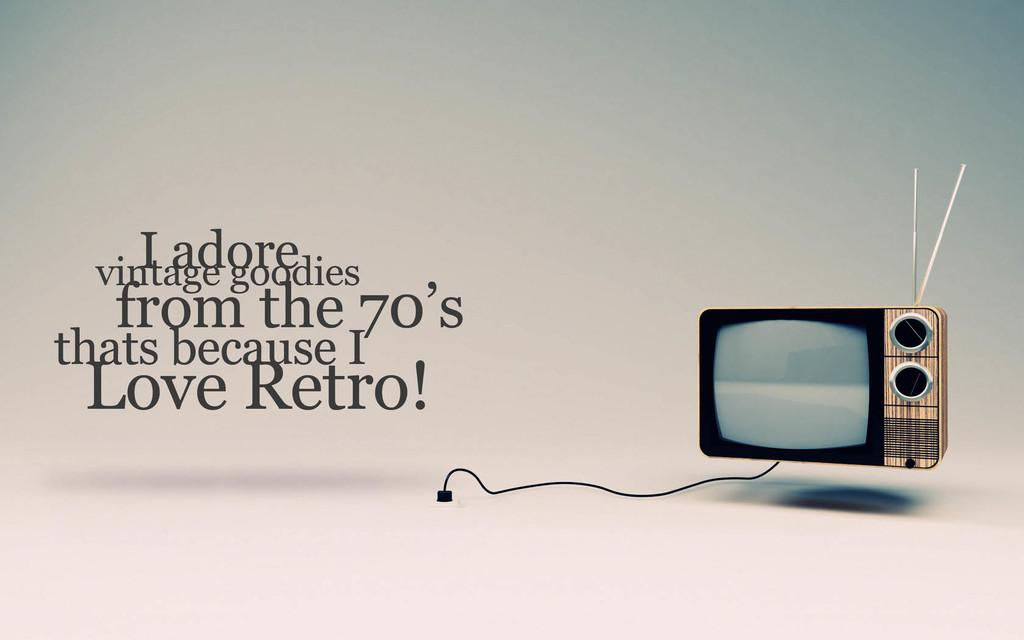<image>
Create a compact narrative representing the image presented. An ad from Ladore for a 70's show and a retro TV. 